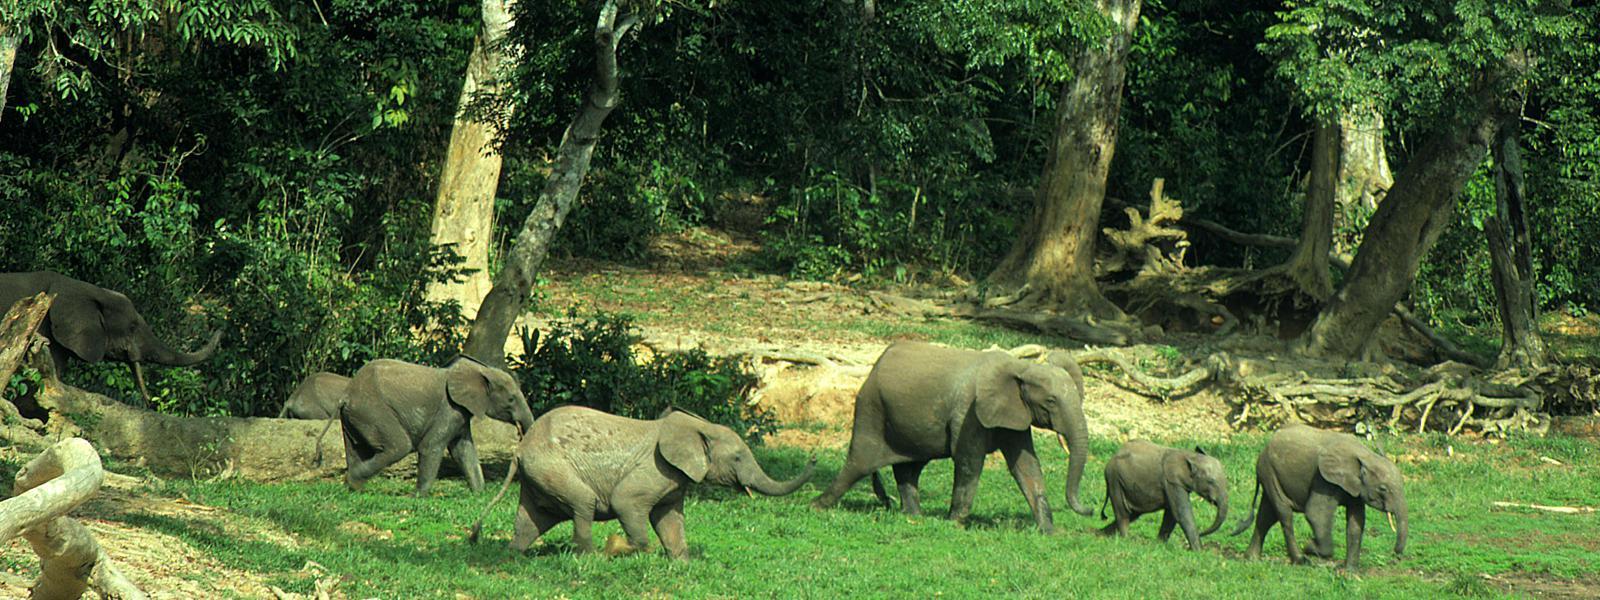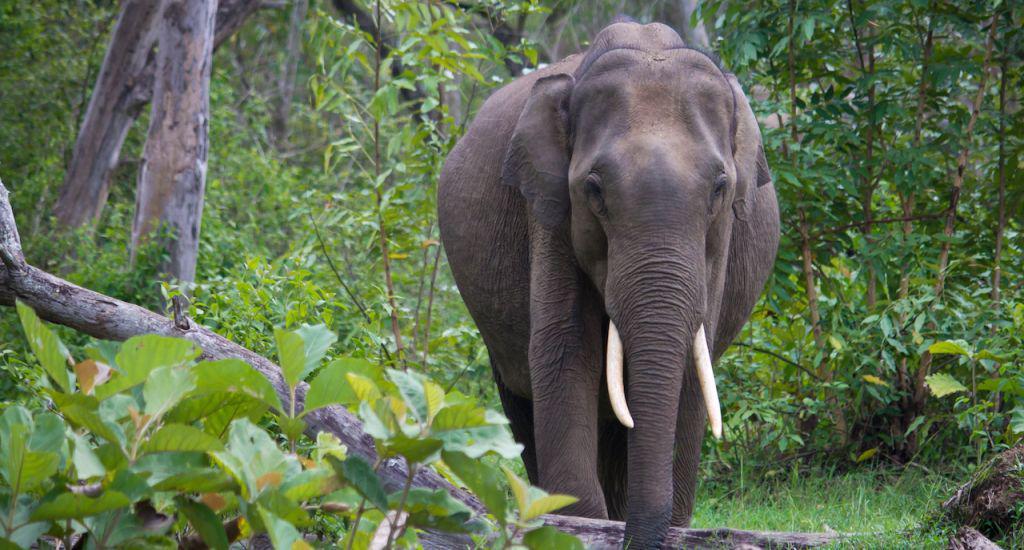The first image is the image on the left, the second image is the image on the right. For the images shown, is this caption "Two elephants are in the grassy wilderness." true? Answer yes or no. No. The first image is the image on the left, the second image is the image on the right. For the images displayed, is the sentence "An image shows a camera-facing elephant with tusks and trunk pointed downward." factually correct? Answer yes or no. Yes. 